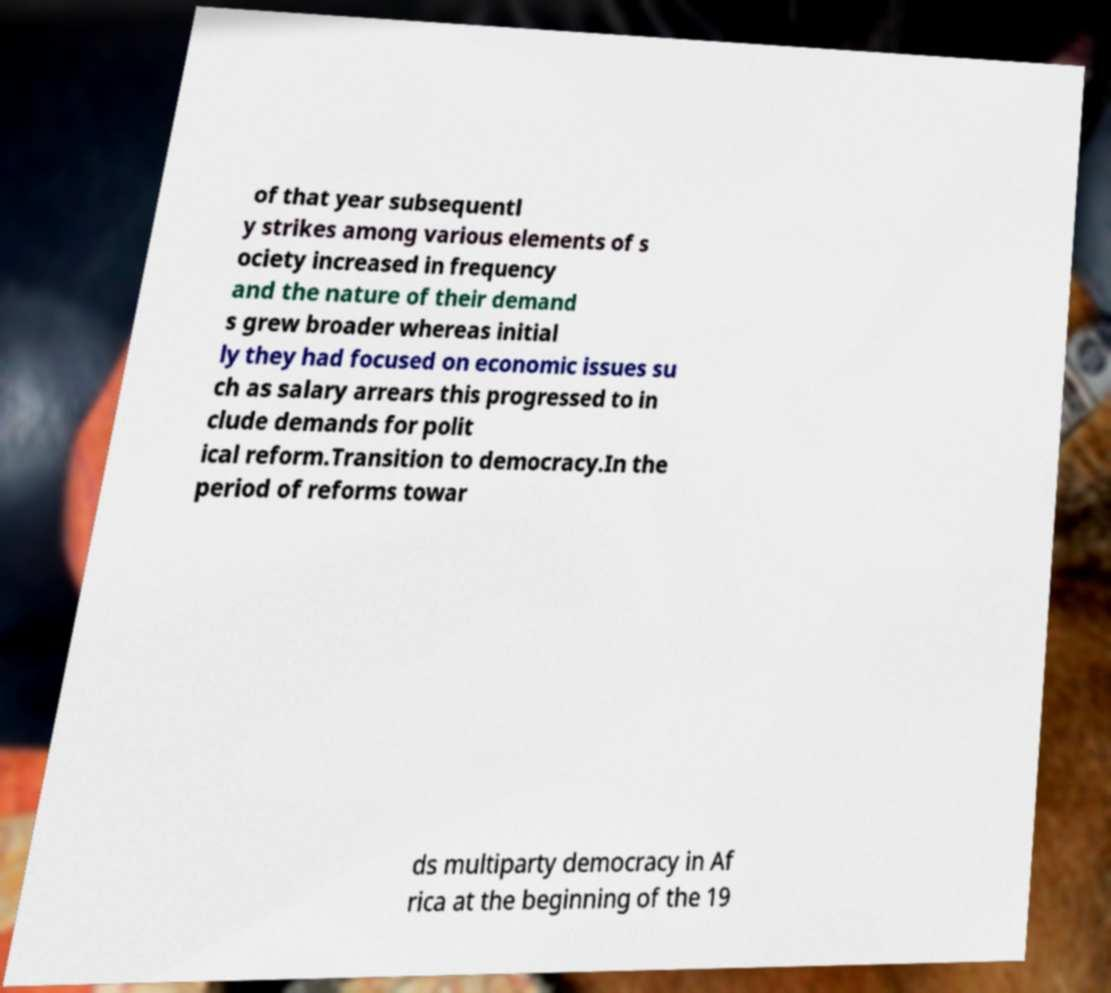Can you read and provide the text displayed in the image?This photo seems to have some interesting text. Can you extract and type it out for me? of that year subsequentl y strikes among various elements of s ociety increased in frequency and the nature of their demand s grew broader whereas initial ly they had focused on economic issues su ch as salary arrears this progressed to in clude demands for polit ical reform.Transition to democracy.In the period of reforms towar ds multiparty democracy in Af rica at the beginning of the 19 